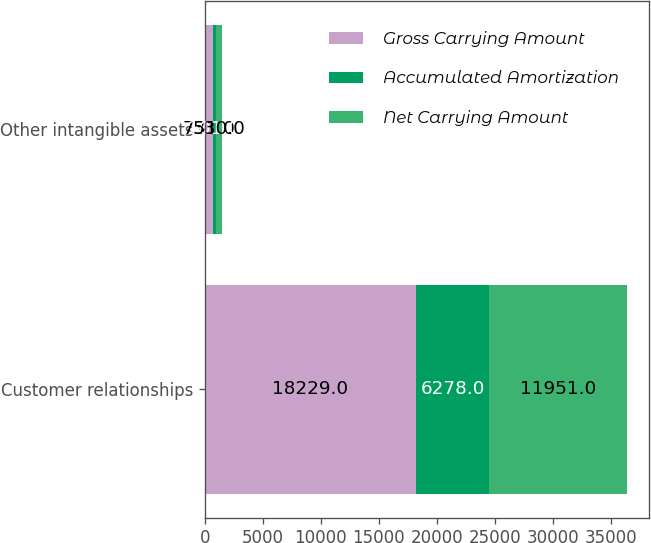<chart> <loc_0><loc_0><loc_500><loc_500><stacked_bar_chart><ecel><fcel>Customer relationships<fcel>Other intangible assets<nl><fcel>Gross Carrying Amount<fcel>18229<fcel>731<nl><fcel>Accumulated Amortization<fcel>6278<fcel>201<nl><fcel>Net Carrying Amount<fcel>11951<fcel>530<nl></chart> 